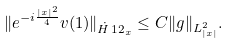<formula> <loc_0><loc_0><loc_500><loc_500>\| e ^ { - { i } \frac { | x | ^ { 2 } } { 4 } } v ( 1 ) \| _ { \dot { H } ^ { } { 1 } 2 _ { x } } \leq C \| g \| _ { L ^ { 2 } _ { | x | } } .</formula> 